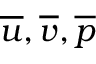<formula> <loc_0><loc_0><loc_500><loc_500>\overline { u } , \overline { v } , \overline { p }</formula> 